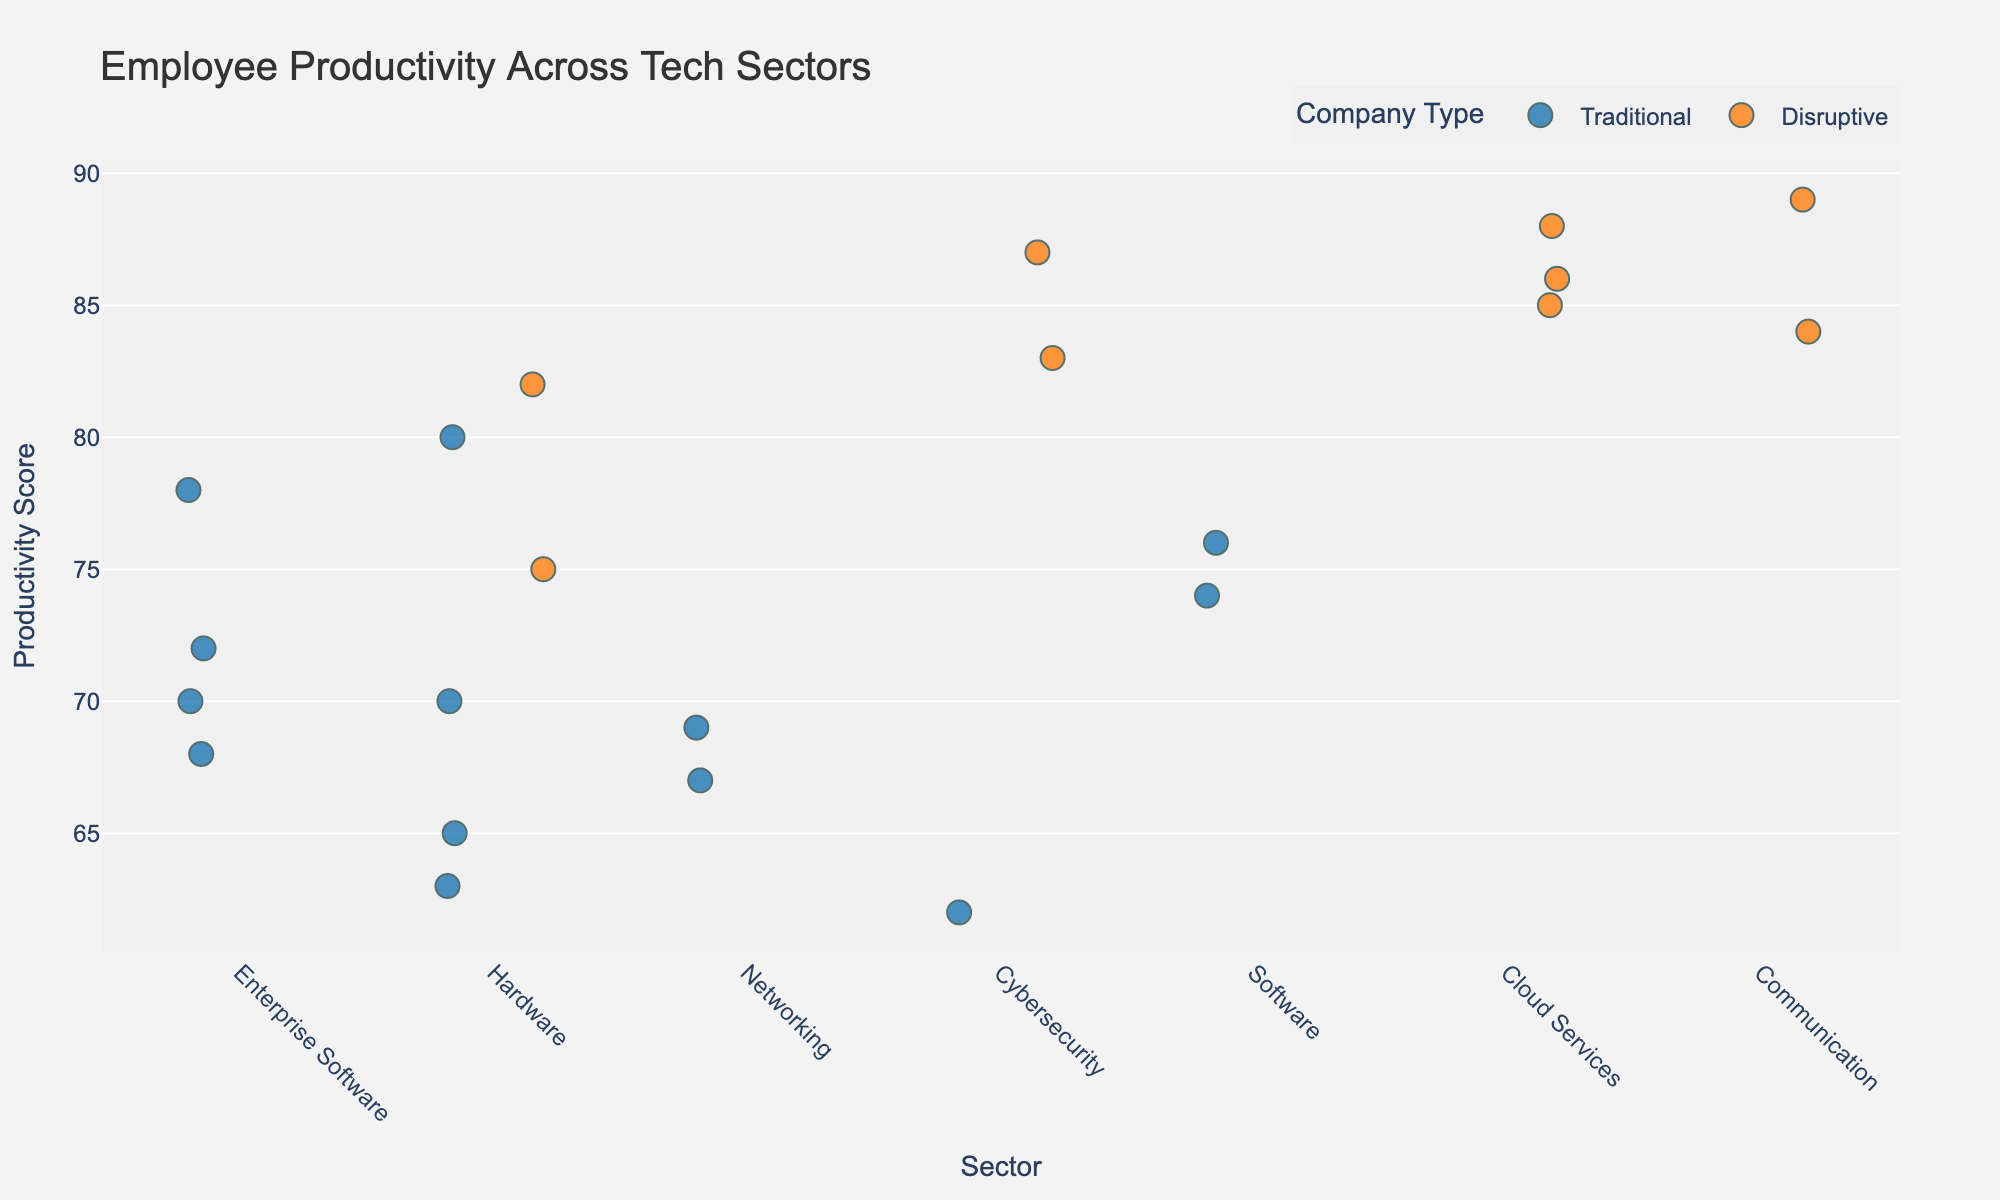Which sector has the highest productivity score? By examining the figure, the highest productivity score is seen in the Communication sector with a score of 89 for Zoom.
Answer: Communication How many disruptive companies are in the Cloud Services sector? The figure shows specific points: Salesforce, Amazon Web Services, and Google Cloud are all disruptive companies in the Cloud Services sector.
Answer: 3 What is the average productivity score for disruptive companies in the Cybersecurity sector? Disruptive companies in the Cybersecurity sector are Palo Alto Networks and Crowdstrike with scores 83 and 87. Calculating (83 + 87) / 2 gives 85.
Answer: 85 Which traditional company in the Hardware sector has the highest productivity score? In the Hardware sector, traditional companies listed are Dell, HP, Apple, and Intel with scores of 65, 63, 80, and 70, respectively. Apple has the highest score among them at 80.
Answer: Apple How does the average productivity score of traditional companies compare to disruptive companies in the Enterprise Software sector? For traditional companies: IBM (72), Oracle (68), SAP (70), Microsoft (78). Average is (72 + 68 + 70 + 78) / 4 = 72. For disruptive companies, there are no entries in Enterprise Software.
Answer: Traditional: 72, Disruptive: N/A What is the overall median productivity score for disruptive companies across all sectors? Disruptive companies have scores: Salesforce (85), AWS (88), Google Cloud (86), Nvidia (82), AMD (75), Palo Alto Networks (83), Crowdstrike (87), Zoom (89), Slack (84). Sorting: 75, 82, 83, 84, 85, 86, 87, 88, 89. Median is the middle value, which is 85.
Answer: 85 Which sector shows the widest range in productivity scores? To determine the widest range, compare the max and min scores in each sector. For each sector: Enterprise Software (78-68=10), Cloud Services (88-85=3), Hardware (82-63=19), Networking (69-67=2), Cybersecurity (87-62=25), Software (76-74=2), Communication (89-84=5). Cybersecurity has the widest range of 25.
Answer: Cybersecurity Are there more traditional or disruptive companies in the dataset? Counting the instances, traditional: IBM, Oracle, SAP, Microsoft, Dell, HP, Apple, Intel, Cisco, Juniper, Symantec, Adobe, Autodesk (13). Disruptive: Salesforce, AWS, Google Cloud, Nvidia, AMD, Palo Alto Networks, Crowdstrike, Zoom, Slack (9).
Answer: More traditional Which traditional company has the lowest productivity score? Examining the traditional companies: HP (63), is the lowest among IBM, Oracle, SAP, Microsoft, Dell, Apple, Intel, Cisco, Juniper, Symantec, Adobe, Autodesk.
Answer: HP How many sectors have at least one disruptive company? Checking each sector: Enterprise Software (0), Cloud Services (3), Hardware (2), Networking (0), Cybersecurity (2), Software (0), Communication (2). 3 sectors (Cloud Services, Hardware, Cybersecurity, Communication).
Answer: 4 